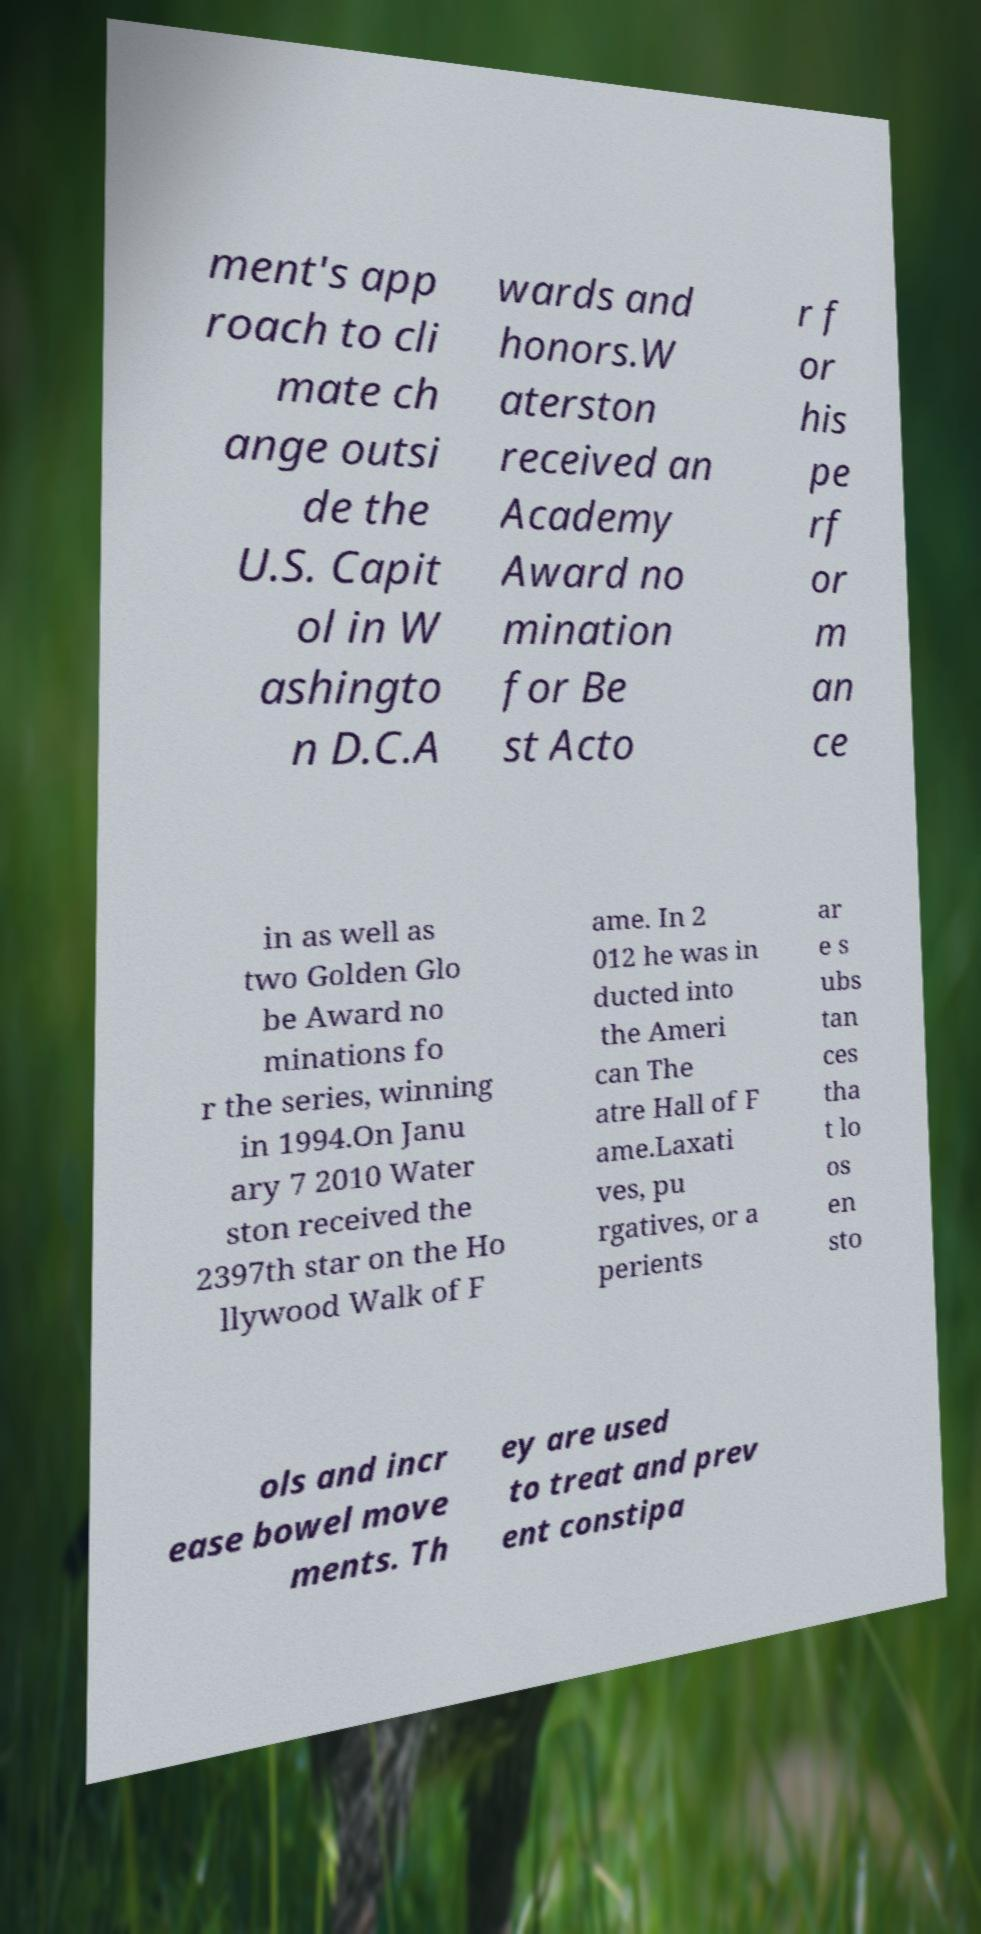For documentation purposes, I need the text within this image transcribed. Could you provide that? ment's app roach to cli mate ch ange outsi de the U.S. Capit ol in W ashingto n D.C.A wards and honors.W aterston received an Academy Award no mination for Be st Acto r f or his pe rf or m an ce in as well as two Golden Glo be Award no minations fo r the series, winning in 1994.On Janu ary 7 2010 Water ston received the 2397th star on the Ho llywood Walk of F ame. In 2 012 he was in ducted into the Ameri can The atre Hall of F ame.Laxati ves, pu rgatives, or a perients ar e s ubs tan ces tha t lo os en sto ols and incr ease bowel move ments. Th ey are used to treat and prev ent constipa 